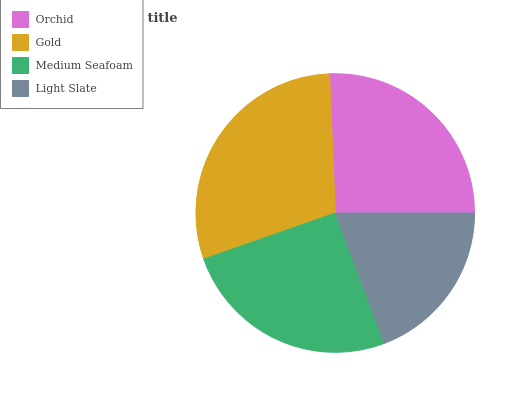Is Light Slate the minimum?
Answer yes or no. Yes. Is Gold the maximum?
Answer yes or no. Yes. Is Medium Seafoam the minimum?
Answer yes or no. No. Is Medium Seafoam the maximum?
Answer yes or no. No. Is Gold greater than Medium Seafoam?
Answer yes or no. Yes. Is Medium Seafoam less than Gold?
Answer yes or no. Yes. Is Medium Seafoam greater than Gold?
Answer yes or no. No. Is Gold less than Medium Seafoam?
Answer yes or no. No. Is Orchid the high median?
Answer yes or no. Yes. Is Medium Seafoam the low median?
Answer yes or no. Yes. Is Medium Seafoam the high median?
Answer yes or no. No. Is Orchid the low median?
Answer yes or no. No. 